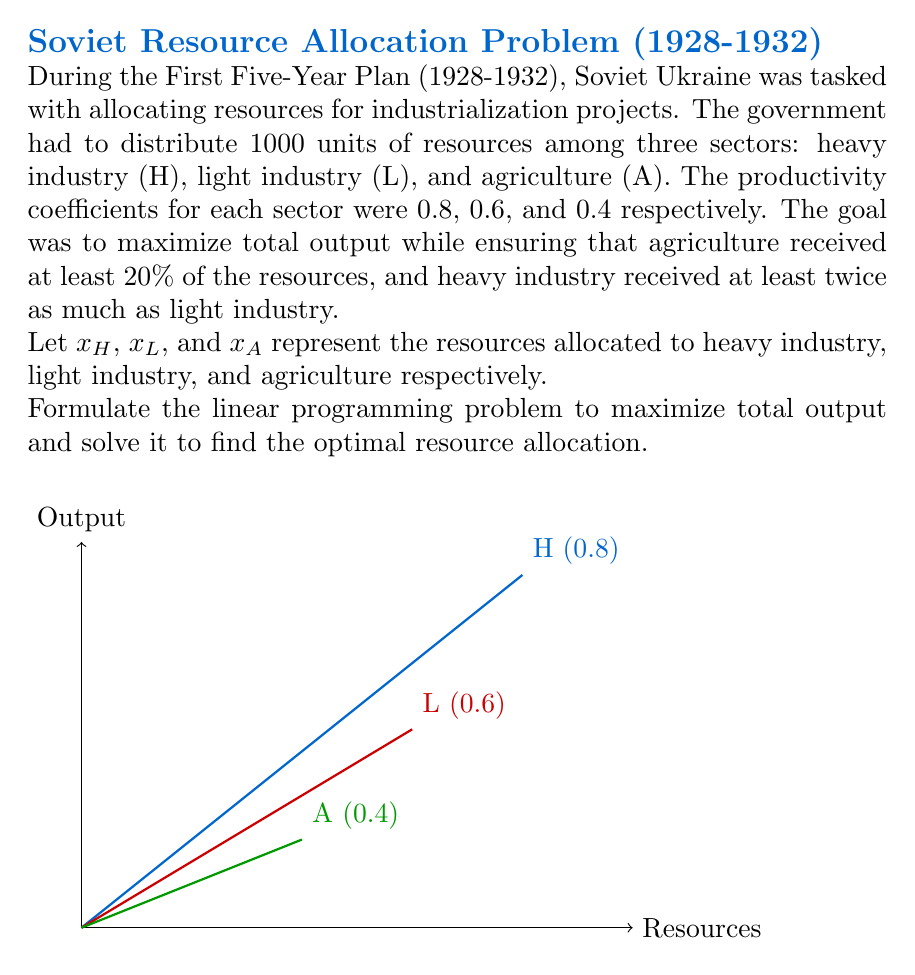Can you solve this math problem? Let's approach this step-by-step:

1) First, we need to formulate the objective function. The total output is the sum of the products of resources allocated to each sector and their respective productivity coefficients:

   Maximize: $Z = 0.8x_H + 0.6x_L + 0.4x_A$

2) Now, we need to set up the constraints:

   a) Total resources: $x_H + x_L + x_A = 1000$
   b) Agriculture gets at least 20%: $x_A \geq 0.2 \times 1000 = 200$
   c) Heavy industry gets at least twice as much as light industry: $x_H \geq 2x_L$
   d) Non-negativity: $x_H, x_L, x_A \geq 0$

3) The complete linear programming problem:

   Maximize: $Z = 0.8x_H + 0.6x_L + 0.4x_A$
   Subject to:
   $x_H + x_L + x_A = 1000$
   $x_A \geq 200$
   $x_H \geq 2x_L$
   $x_H, x_L, x_A \geq 0$

4) To solve this, we can use the simplex method or graphical method. Given the constraints, we can deduce:

   - Agriculture will get the minimum 200 units (as it has the lowest productivity).
   - Heavy industry will get exactly twice as much as light industry to maximize output.

5) Let $x_L = y$. Then $x_H = 2y$ and $x_A = 200$.

6) Substituting into the total resources constraint:
   $2y + y + 200 = 1000$
   $3y = 800$
   $y = 266.67$

7) Therefore:
   $x_L = 266.67$
   $x_H = 533.33$
   $x_A = 200$

8) The maximum output is:
   $Z = 0.8(533.33) + 0.6(266.67) + 0.4(200) = 626.67$
Answer: Optimal allocation: Heavy Industry: 533.33, Light Industry: 266.67, Agriculture: 200. Maximum output: 626.67. 